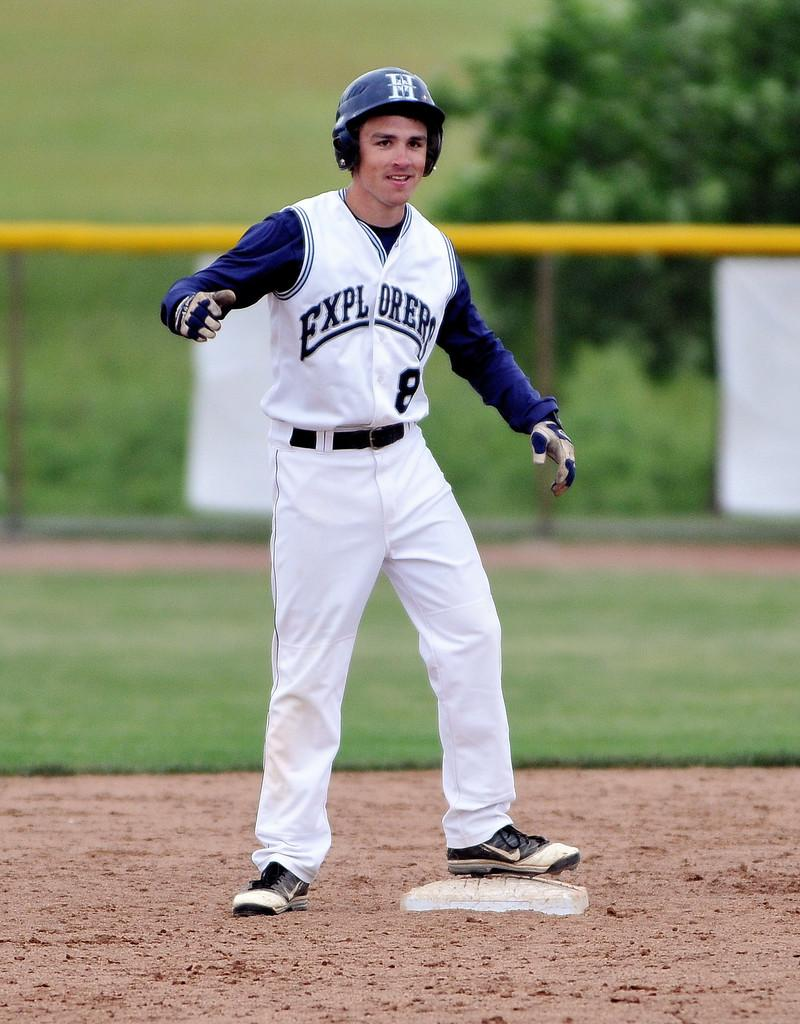<image>
Present a compact description of the photo's key features. A young man with an H on his batting helmet stands on the base. 